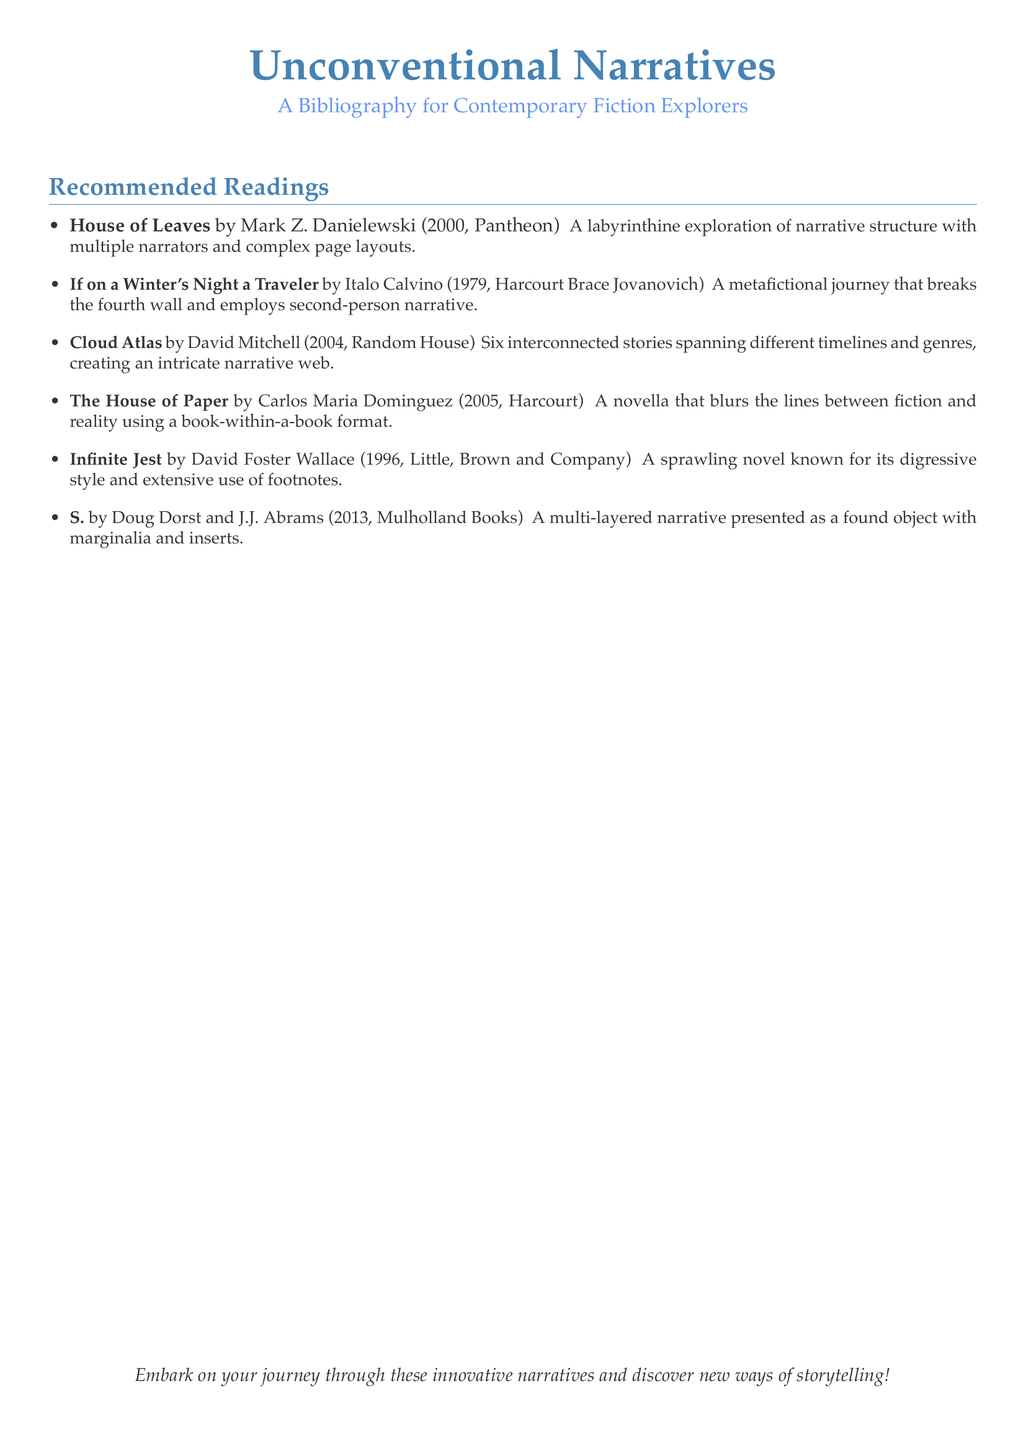What is the title of the bibliography? The title of the bibliography is presented prominently at the top of the document.
Answer: Unconventional Narratives Who is the author of "Cloud Atlas"? This information can be found in the list of recommended readings.
Answer: David Mitchell In what year was "If on a Winter's Night a Traveler" published? The year of publication is included next to each book entry.
Answer: 1979 Which book is known for its extensive use of footnotes? This requires knowledge of the specific works listed.
Answer: Infinite Jest How many interconnected stories are in "Cloud Atlas"? The description specifies the number of stories contained within.
Answer: Six What type of narrative structure is used in "S."? The description elaborates on the nature of the narrative form.
Answer: Multi-layered narrative Who published "House of Leaves"? The publisher name is noted next to the book title in the bibliography.
Answer: Pantheon What is the main theme of "The House of Paper"? The brief description offers insights into the theme explored in the book.
Answer: Blurs lines between fiction and reality What is the subtitle of this bibliography? The subtitle is clearly stated below the main title of the document.
Answer: A Bibliography for Contemporary Fiction Explorers 